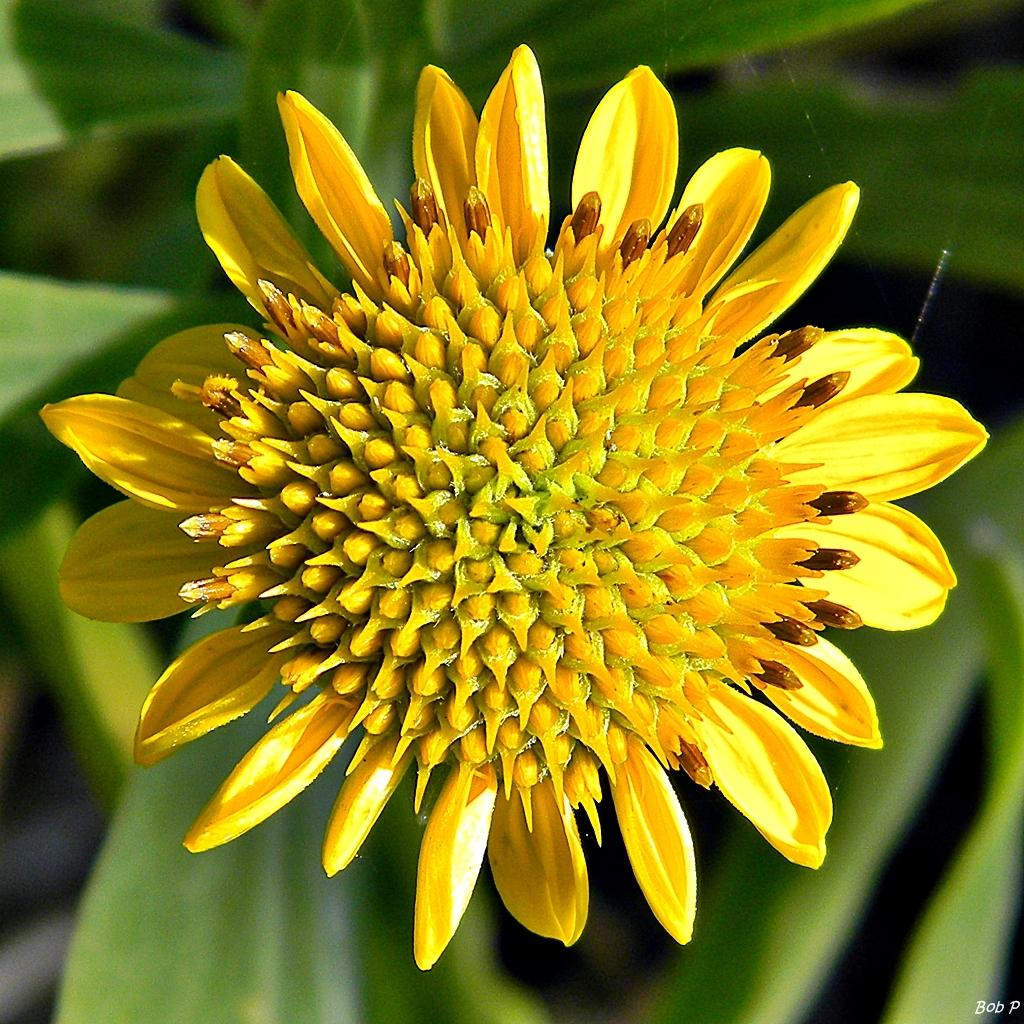What type of flower is in the image? There is a yellow flower in the image. What other parts of the flower can be seen besides the petals? The flower has leaves. What type of surprise is hidden in the patch in the image? There is no patch or surprise present in the image; it only features a yellow flower with leaves. 